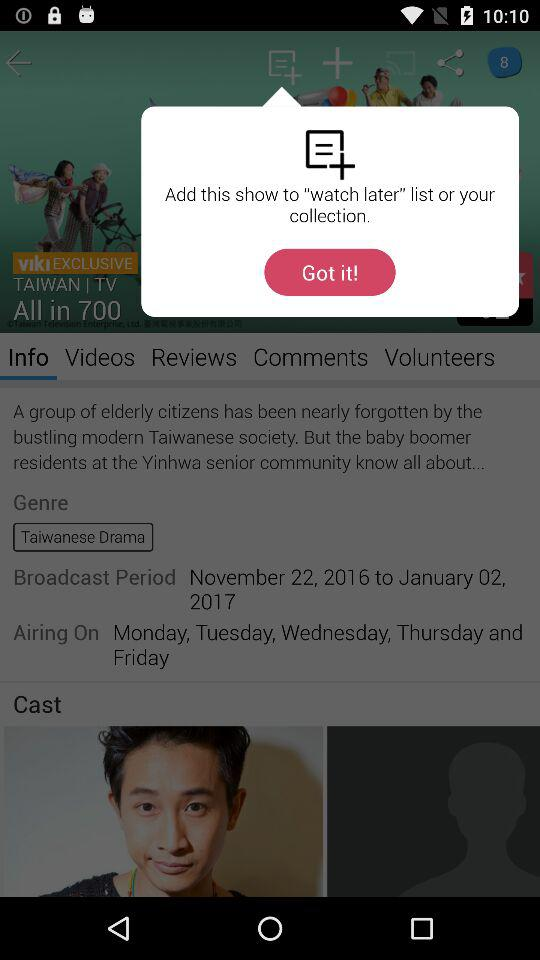What is the broadcast period of the drama? The broadcast period of the drama is from November 22, 2016 to January 02, 2017. 